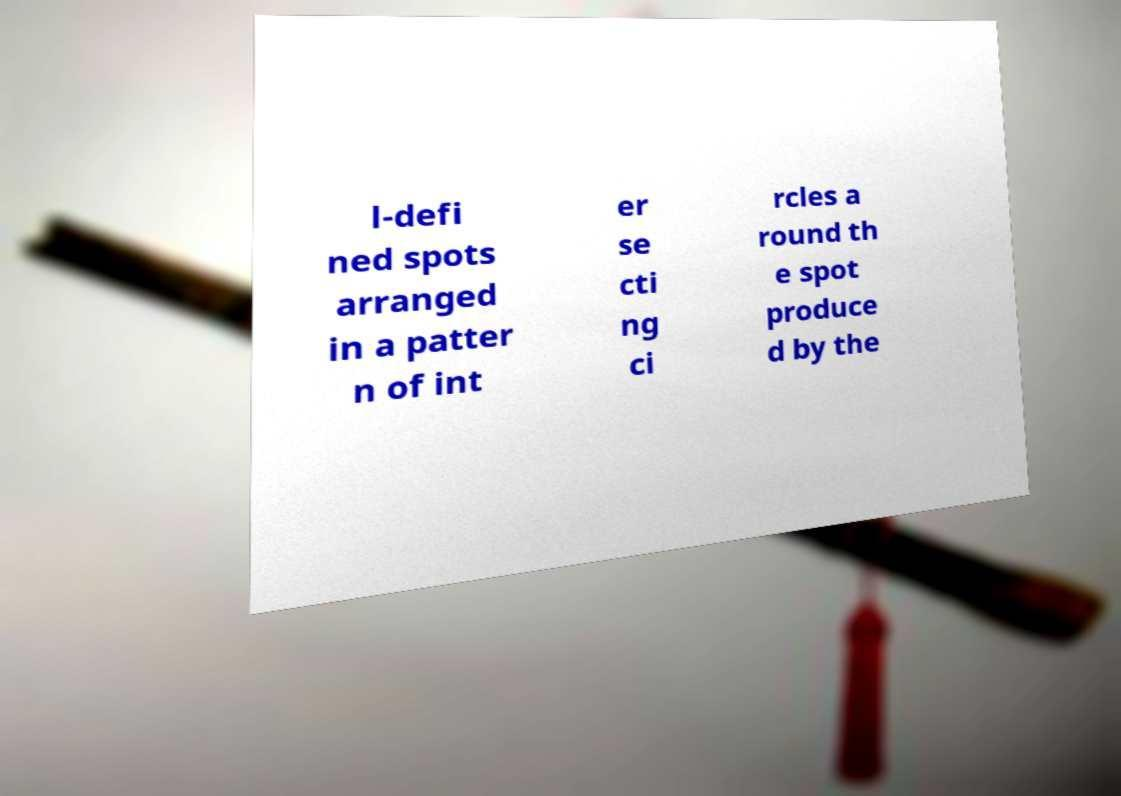Please identify and transcribe the text found in this image. l-defi ned spots arranged in a patter n of int er se cti ng ci rcles a round th e spot produce d by the 